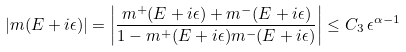Convert formula to latex. <formula><loc_0><loc_0><loc_500><loc_500>| m ( E + i \epsilon ) | = \left | \frac { m ^ { + } ( E + i \epsilon ) + m ^ { - } ( E + i \epsilon ) } { 1 - m ^ { + } ( E + i \epsilon ) m ^ { - } ( E + i \epsilon ) } \right | \leq C _ { 3 } \, \epsilon ^ { \alpha - 1 }</formula> 